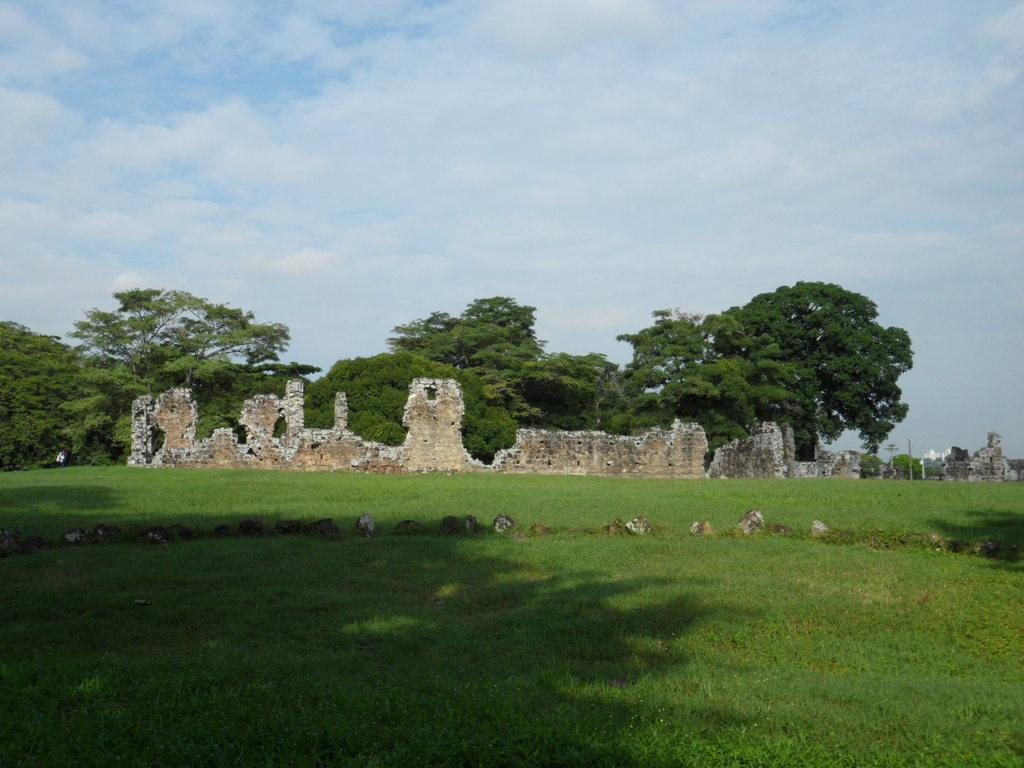What can be seen at the bottom of the image? There are shadows of trees at the bottom of the image. What type of vegetation is present on the ground? The ground has grass. What can be seen in the background of the image? There are rocks, walls, and trees in the background. What is visible in the sky? There are clouds in the sky. Who is the writer in the image? There is no writer present in the image. What type of amusement can be seen in the image? There is no amusement present in the image; it features shadows of trees, grass, rocks, walls, trees, and clouds. 